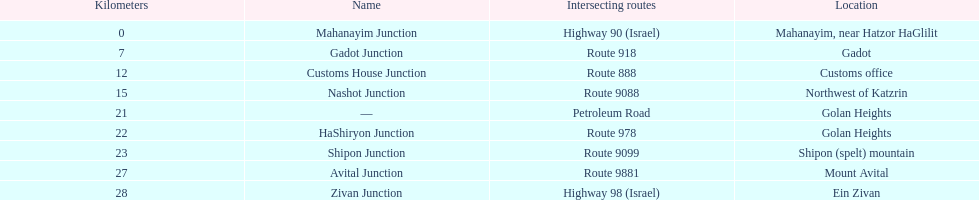Which junction on highway 91 is closer to ein zivan, gadot junction or shipon junction? Gadot Junction. I'm looking to parse the entire table for insights. Could you assist me with that? {'header': ['Kilometers', 'Name', 'Intersecting routes', 'Location'], 'rows': [['0', 'Mahanayim Junction', 'Highway 90 (Israel)', 'Mahanayim, near Hatzor HaGlilit'], ['7', 'Gadot Junction', 'Route 918', 'Gadot'], ['12', 'Customs House Junction', 'Route 888', 'Customs office'], ['15', 'Nashot Junction', 'Route 9088', 'Northwest of Katzrin'], ['21', '—', 'Petroleum Road', 'Golan Heights'], ['22', 'HaShiryon Junction', 'Route 978', 'Golan Heights'], ['23', 'Shipon Junction', 'Route 9099', 'Shipon (spelt) mountain'], ['27', 'Avital Junction', 'Route 9881', 'Mount Avital'], ['28', 'Zivan Junction', 'Highway 98 (Israel)', 'Ein Zivan']]} 